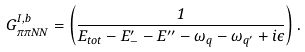Convert formula to latex. <formula><loc_0><loc_0><loc_500><loc_500>G _ { \pi \pi N N } ^ { I , b } = \left ( \frac { 1 } { E _ { t o t } - E _ { - } ^ { \prime } - E ^ { \prime \prime } - \omega _ { q } - \omega _ { q ^ { \prime } } + i \epsilon } \right ) .</formula> 